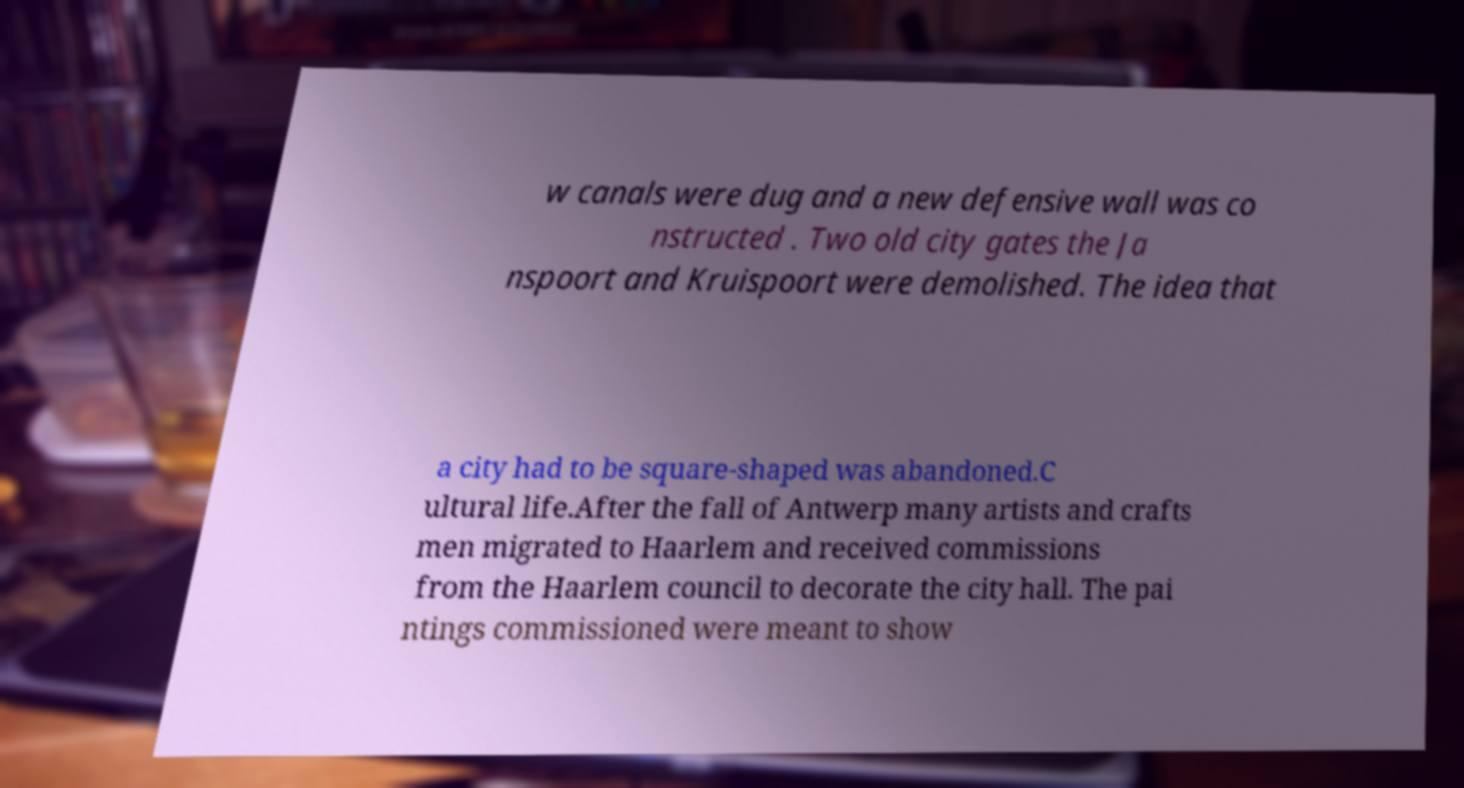What messages or text are displayed in this image? I need them in a readable, typed format. w canals were dug and a new defensive wall was co nstructed . Two old city gates the Ja nspoort and Kruispoort were demolished. The idea that a city had to be square-shaped was abandoned.C ultural life.After the fall of Antwerp many artists and crafts men migrated to Haarlem and received commissions from the Haarlem council to decorate the city hall. The pai ntings commissioned were meant to show 